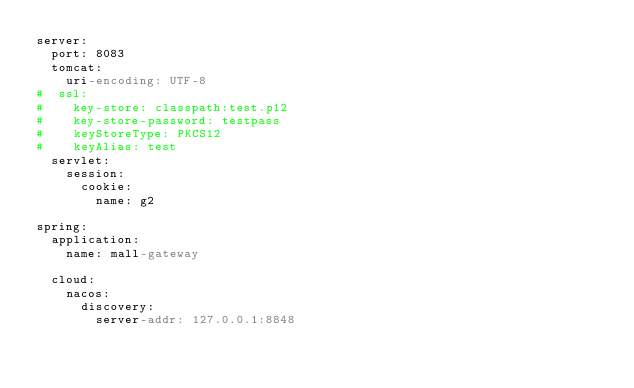Convert code to text. <code><loc_0><loc_0><loc_500><loc_500><_YAML_>server:
  port: 8083
  tomcat:
    uri-encoding: UTF-8
#  ssl:
#    key-store: classpath:test.p12
#    key-store-password: testpass
#    keyStoreType: PKCS12
#    keyAlias: test
  servlet:
    session:
      cookie:
        name: g2

spring:
  application:
    name: mall-gateway

  cloud:
    nacos:
      discovery:
        server-addr: 127.0.0.1:8848</code> 